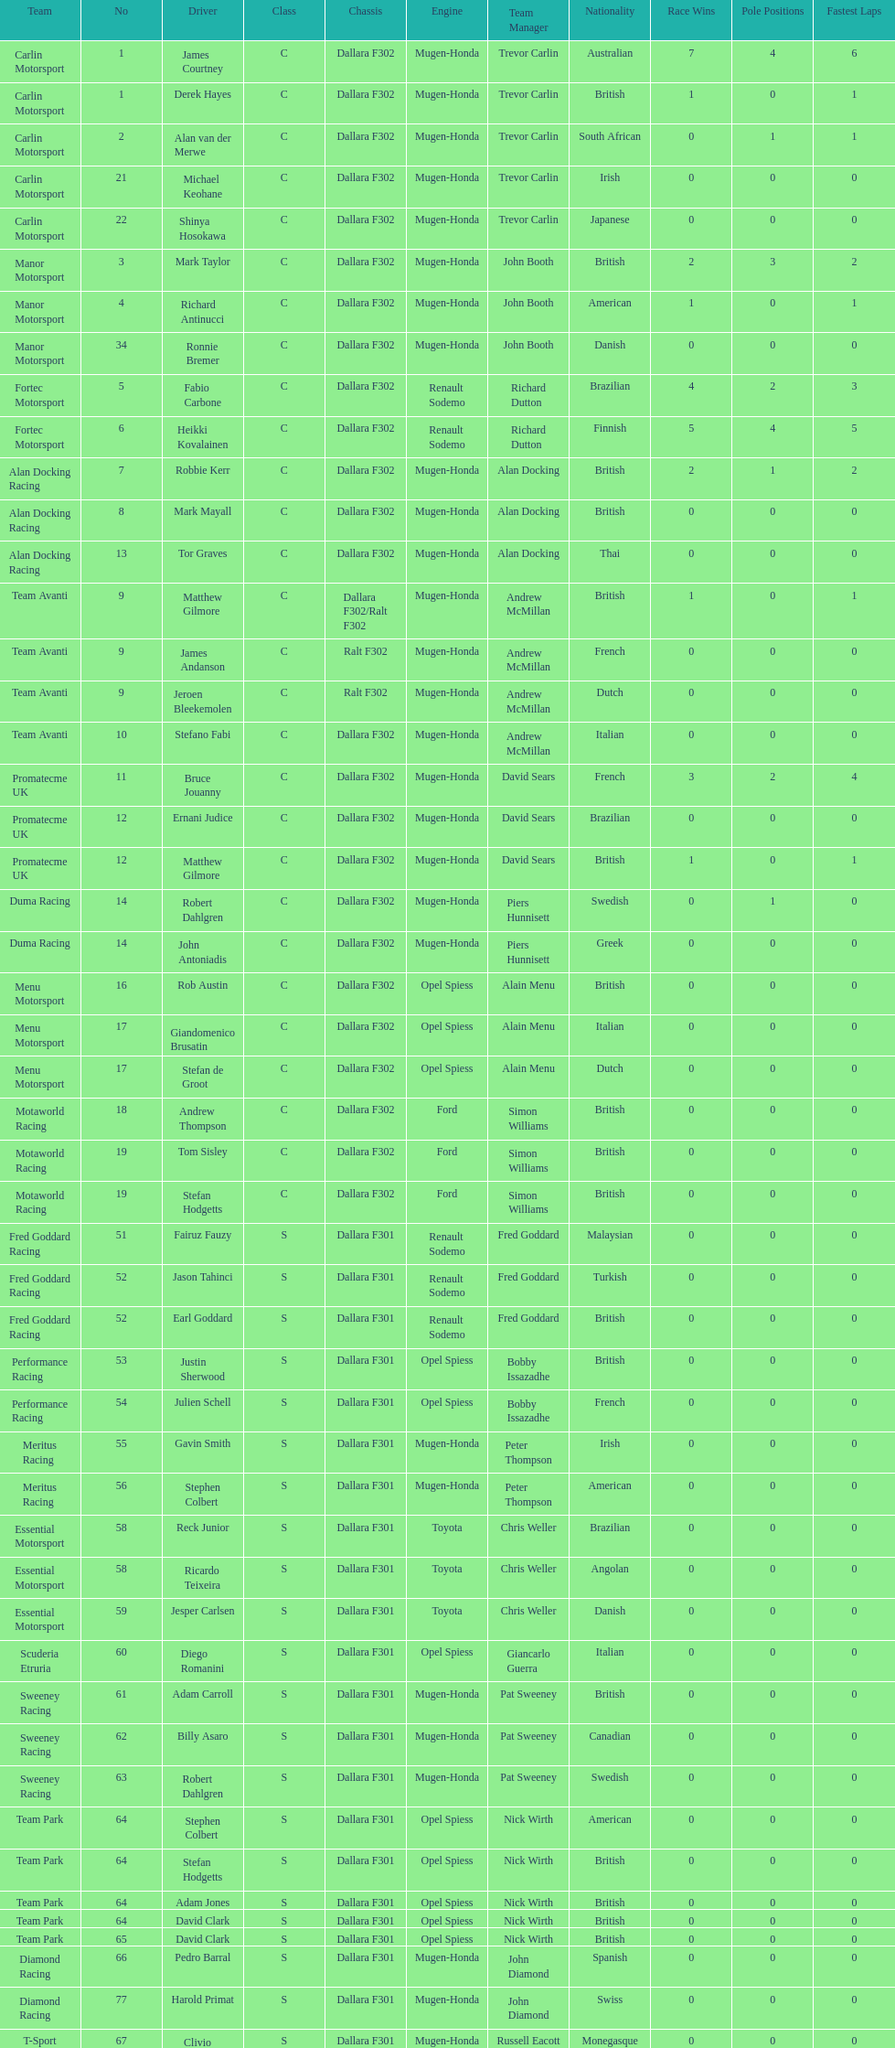How many teams had at least two drivers this season? 17. 